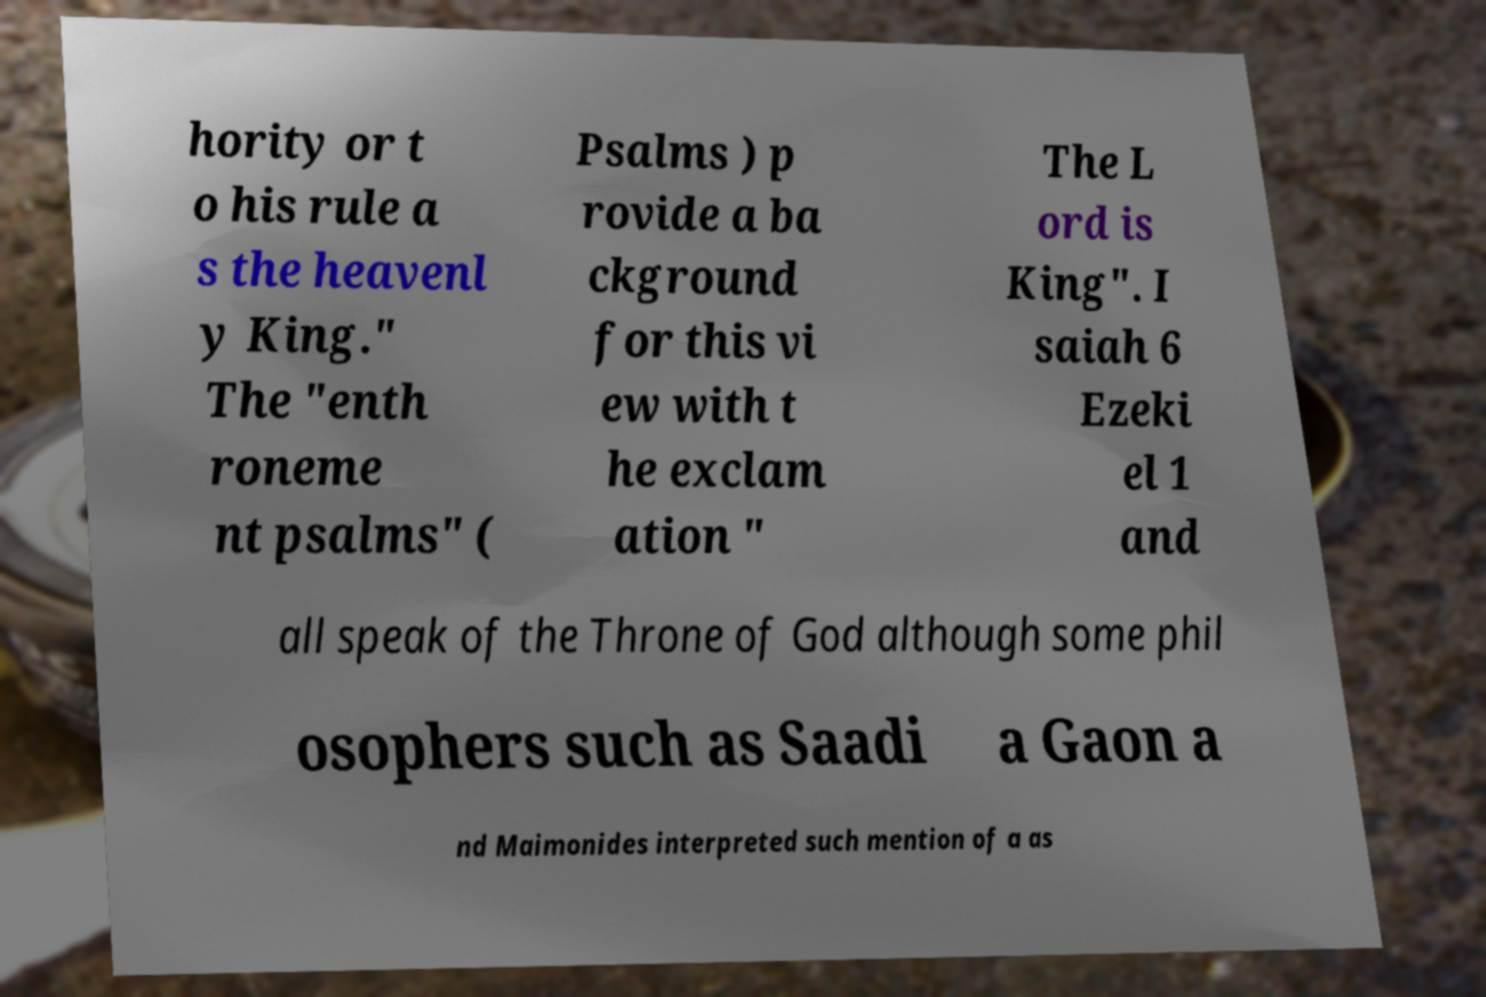Please identify and transcribe the text found in this image. hority or t o his rule a s the heavenl y King." The "enth roneme nt psalms" ( Psalms ) p rovide a ba ckground for this vi ew with t he exclam ation " The L ord is King". I saiah 6 Ezeki el 1 and all speak of the Throne of God although some phil osophers such as Saadi a Gaon a nd Maimonides interpreted such mention of a as 